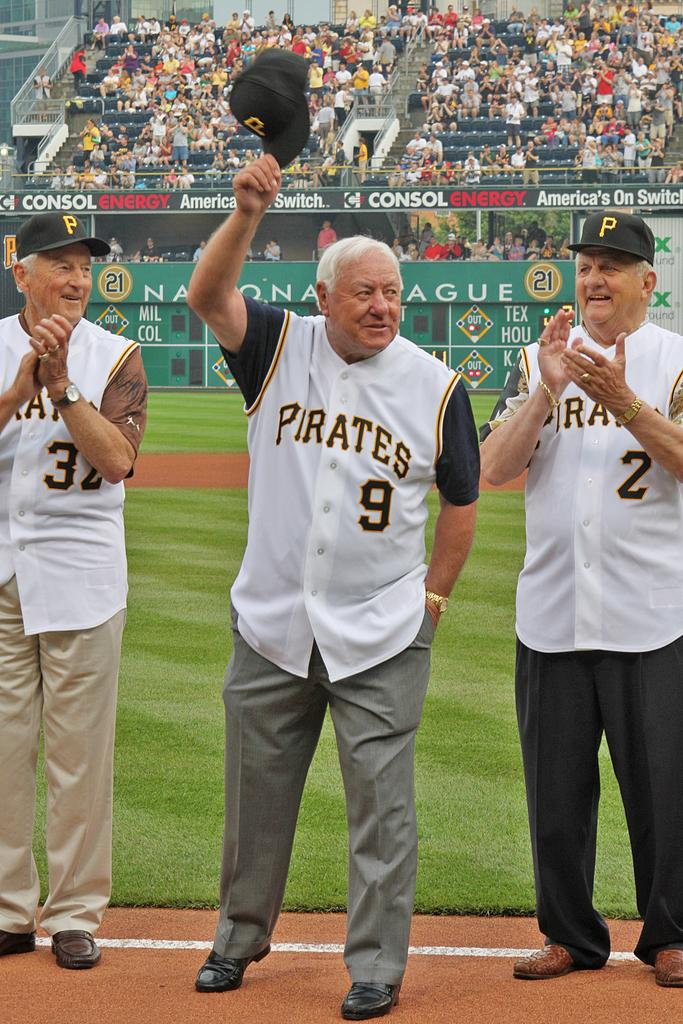<image>
Provide a brief description of the given image. Men clapping that are on the baseball field wearing jerseys with Pirates on the front. 